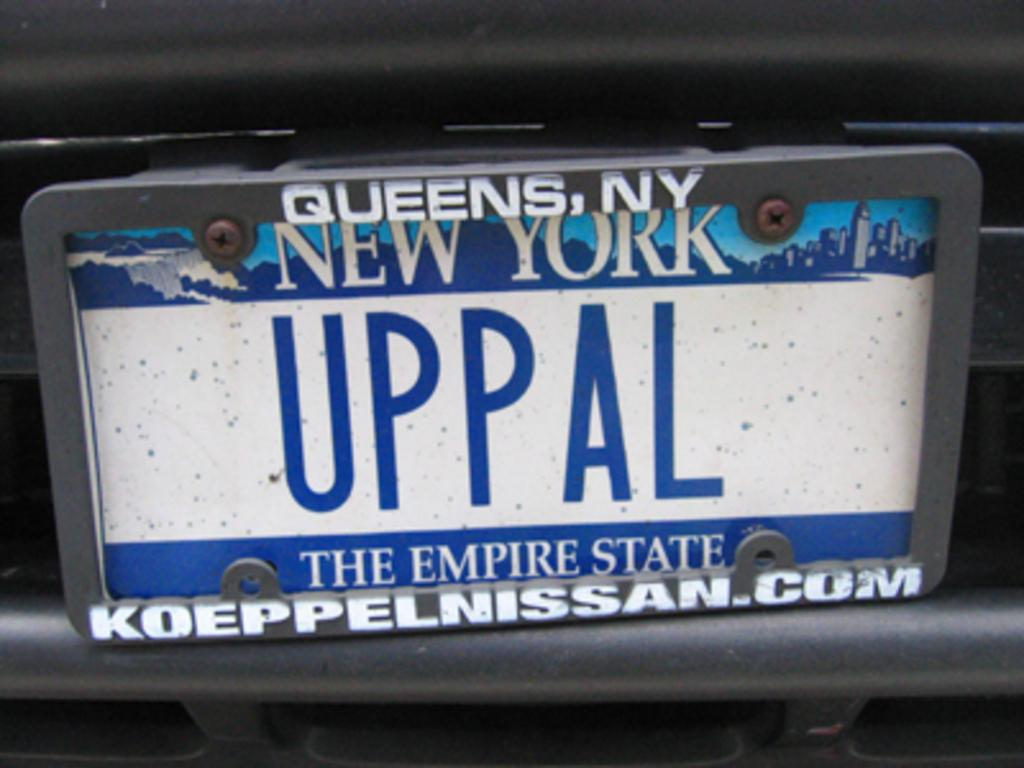What object is present in the image that displays a name or identification? There is a name board in the image. Where is the name board located? The name board is attached to a vehicle. What colors are used for the text on the name board? The text on the name board is in white and blue colors. What type of stew is being cooked in the image? There is no stew present in the image; it features a name board attached to a vehicle with white and blue text. How many feet are visible in the image? There are no feet visible in the image; it only shows a name board attached to a vehicle with white and blue text. 